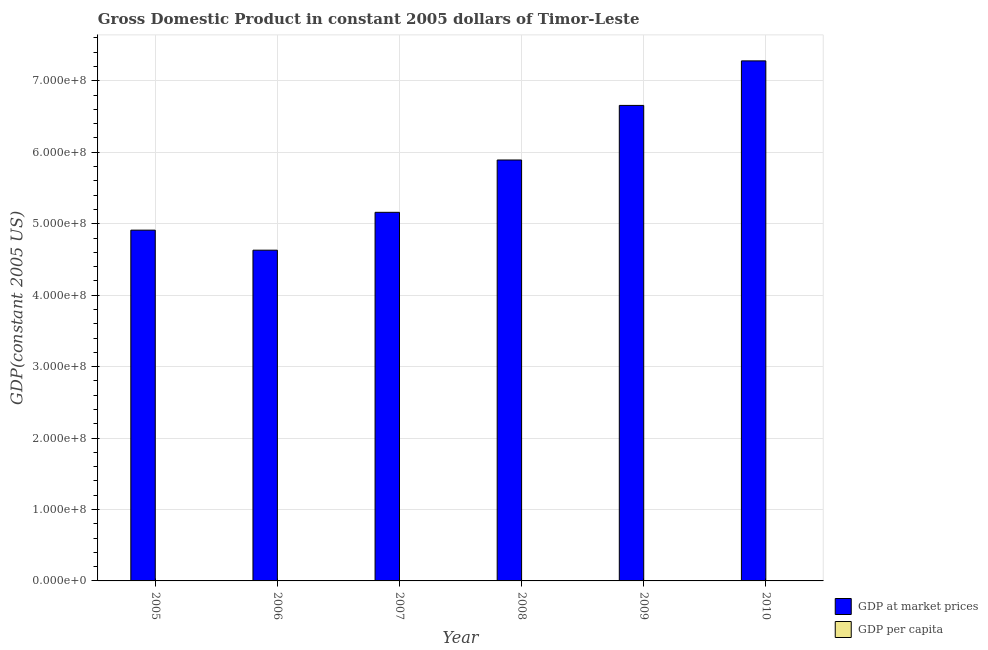How many different coloured bars are there?
Offer a very short reply. 2. How many groups of bars are there?
Give a very brief answer. 6. Are the number of bars per tick equal to the number of legend labels?
Ensure brevity in your answer.  Yes. How many bars are there on the 5th tick from the left?
Provide a short and direct response. 2. How many bars are there on the 1st tick from the right?
Ensure brevity in your answer.  2. In how many cases, is the number of bars for a given year not equal to the number of legend labels?
Your answer should be compact. 0. What is the gdp per capita in 2009?
Offer a very short reply. 634.87. Across all years, what is the maximum gdp per capita?
Offer a very short reply. 682.6. Across all years, what is the minimum gdp per capita?
Provide a short and direct response. 464.78. In which year was the gdp at market prices maximum?
Give a very brief answer. 2010. In which year was the gdp per capita minimum?
Offer a very short reply. 2006. What is the total gdp at market prices in the graph?
Your answer should be compact. 3.45e+09. What is the difference between the gdp per capita in 2007 and that in 2009?
Your response must be concise. -125.65. What is the difference between the gdp at market prices in 2010 and the gdp per capita in 2007?
Offer a very short reply. 2.12e+08. What is the average gdp at market prices per year?
Keep it short and to the point. 5.75e+08. In the year 2007, what is the difference between the gdp per capita and gdp at market prices?
Your answer should be very brief. 0. In how many years, is the gdp per capita greater than 40000000 US$?
Your answer should be very brief. 0. What is the ratio of the gdp at market prices in 2006 to that in 2010?
Ensure brevity in your answer.  0.64. What is the difference between the highest and the second highest gdp per capita?
Keep it short and to the point. 47.73. What is the difference between the highest and the lowest gdp at market prices?
Your answer should be compact. 2.65e+08. What does the 2nd bar from the left in 2006 represents?
Your response must be concise. GDP per capita. What does the 2nd bar from the right in 2010 represents?
Keep it short and to the point. GDP at market prices. Are all the bars in the graph horizontal?
Your answer should be compact. No. How many years are there in the graph?
Your answer should be very brief. 6. What is the difference between two consecutive major ticks on the Y-axis?
Your answer should be compact. 1.00e+08. Does the graph contain any zero values?
Your answer should be very brief. No. Does the graph contain grids?
Give a very brief answer. Yes. How many legend labels are there?
Make the answer very short. 2. How are the legend labels stacked?
Ensure brevity in your answer.  Vertical. What is the title of the graph?
Make the answer very short. Gross Domestic Product in constant 2005 dollars of Timor-Leste. What is the label or title of the Y-axis?
Ensure brevity in your answer.  GDP(constant 2005 US). What is the GDP(constant 2005 US) in GDP at market prices in 2005?
Make the answer very short. 4.91e+08. What is the GDP(constant 2005 US) of GDP per capita in 2005?
Your answer should be compact. 501.43. What is the GDP(constant 2005 US) of GDP at market prices in 2006?
Keep it short and to the point. 4.63e+08. What is the GDP(constant 2005 US) in GDP per capita in 2006?
Make the answer very short. 464.78. What is the GDP(constant 2005 US) of GDP at market prices in 2007?
Your answer should be compact. 5.16e+08. What is the GDP(constant 2005 US) of GDP per capita in 2007?
Make the answer very short. 509.22. What is the GDP(constant 2005 US) in GDP at market prices in 2008?
Make the answer very short. 5.89e+08. What is the GDP(constant 2005 US) in GDP per capita in 2008?
Keep it short and to the point. 571.69. What is the GDP(constant 2005 US) in GDP at market prices in 2009?
Give a very brief answer. 6.66e+08. What is the GDP(constant 2005 US) in GDP per capita in 2009?
Give a very brief answer. 634.87. What is the GDP(constant 2005 US) of GDP at market prices in 2010?
Give a very brief answer. 7.28e+08. What is the GDP(constant 2005 US) in GDP per capita in 2010?
Provide a succinct answer. 682.6. Across all years, what is the maximum GDP(constant 2005 US) in GDP at market prices?
Your answer should be compact. 7.28e+08. Across all years, what is the maximum GDP(constant 2005 US) in GDP per capita?
Provide a succinct answer. 682.6. Across all years, what is the minimum GDP(constant 2005 US) in GDP at market prices?
Your answer should be compact. 4.63e+08. Across all years, what is the minimum GDP(constant 2005 US) in GDP per capita?
Your response must be concise. 464.78. What is the total GDP(constant 2005 US) of GDP at market prices in the graph?
Ensure brevity in your answer.  3.45e+09. What is the total GDP(constant 2005 US) of GDP per capita in the graph?
Your answer should be compact. 3364.58. What is the difference between the GDP(constant 2005 US) of GDP at market prices in 2005 and that in 2006?
Make the answer very short. 2.81e+07. What is the difference between the GDP(constant 2005 US) in GDP per capita in 2005 and that in 2006?
Provide a succinct answer. 36.65. What is the difference between the GDP(constant 2005 US) in GDP at market prices in 2005 and that in 2007?
Give a very brief answer. -2.49e+07. What is the difference between the GDP(constant 2005 US) of GDP per capita in 2005 and that in 2007?
Give a very brief answer. -7.79. What is the difference between the GDP(constant 2005 US) in GDP at market prices in 2005 and that in 2008?
Offer a very short reply. -9.82e+07. What is the difference between the GDP(constant 2005 US) of GDP per capita in 2005 and that in 2008?
Offer a very short reply. -70.26. What is the difference between the GDP(constant 2005 US) of GDP at market prices in 2005 and that in 2009?
Keep it short and to the point. -1.75e+08. What is the difference between the GDP(constant 2005 US) of GDP per capita in 2005 and that in 2009?
Provide a succinct answer. -133.44. What is the difference between the GDP(constant 2005 US) of GDP at market prices in 2005 and that in 2010?
Offer a terse response. -2.37e+08. What is the difference between the GDP(constant 2005 US) in GDP per capita in 2005 and that in 2010?
Provide a short and direct response. -181.17. What is the difference between the GDP(constant 2005 US) of GDP at market prices in 2006 and that in 2007?
Ensure brevity in your answer.  -5.30e+07. What is the difference between the GDP(constant 2005 US) of GDP per capita in 2006 and that in 2007?
Keep it short and to the point. -44.44. What is the difference between the GDP(constant 2005 US) of GDP at market prices in 2006 and that in 2008?
Give a very brief answer. -1.26e+08. What is the difference between the GDP(constant 2005 US) of GDP per capita in 2006 and that in 2008?
Your response must be concise. -106.91. What is the difference between the GDP(constant 2005 US) in GDP at market prices in 2006 and that in 2009?
Give a very brief answer. -2.03e+08. What is the difference between the GDP(constant 2005 US) in GDP per capita in 2006 and that in 2009?
Make the answer very short. -170.09. What is the difference between the GDP(constant 2005 US) of GDP at market prices in 2006 and that in 2010?
Give a very brief answer. -2.65e+08. What is the difference between the GDP(constant 2005 US) of GDP per capita in 2006 and that in 2010?
Provide a short and direct response. -217.82. What is the difference between the GDP(constant 2005 US) of GDP at market prices in 2007 and that in 2008?
Ensure brevity in your answer.  -7.33e+07. What is the difference between the GDP(constant 2005 US) of GDP per capita in 2007 and that in 2008?
Make the answer very short. -62.47. What is the difference between the GDP(constant 2005 US) of GDP at market prices in 2007 and that in 2009?
Offer a very short reply. -1.50e+08. What is the difference between the GDP(constant 2005 US) in GDP per capita in 2007 and that in 2009?
Make the answer very short. -125.65. What is the difference between the GDP(constant 2005 US) of GDP at market prices in 2007 and that in 2010?
Make the answer very short. -2.12e+08. What is the difference between the GDP(constant 2005 US) of GDP per capita in 2007 and that in 2010?
Provide a succinct answer. -173.38. What is the difference between the GDP(constant 2005 US) in GDP at market prices in 2008 and that in 2009?
Your answer should be compact. -7.64e+07. What is the difference between the GDP(constant 2005 US) of GDP per capita in 2008 and that in 2009?
Make the answer very short. -63.18. What is the difference between the GDP(constant 2005 US) of GDP at market prices in 2008 and that in 2010?
Keep it short and to the point. -1.39e+08. What is the difference between the GDP(constant 2005 US) of GDP per capita in 2008 and that in 2010?
Ensure brevity in your answer.  -110.91. What is the difference between the GDP(constant 2005 US) of GDP at market prices in 2009 and that in 2010?
Provide a succinct answer. -6.23e+07. What is the difference between the GDP(constant 2005 US) of GDP per capita in 2009 and that in 2010?
Give a very brief answer. -47.73. What is the difference between the GDP(constant 2005 US) of GDP at market prices in 2005 and the GDP(constant 2005 US) of GDP per capita in 2006?
Make the answer very short. 4.91e+08. What is the difference between the GDP(constant 2005 US) of GDP at market prices in 2005 and the GDP(constant 2005 US) of GDP per capita in 2007?
Provide a succinct answer. 4.91e+08. What is the difference between the GDP(constant 2005 US) of GDP at market prices in 2005 and the GDP(constant 2005 US) of GDP per capita in 2008?
Your response must be concise. 4.91e+08. What is the difference between the GDP(constant 2005 US) in GDP at market prices in 2005 and the GDP(constant 2005 US) in GDP per capita in 2009?
Your response must be concise. 4.91e+08. What is the difference between the GDP(constant 2005 US) of GDP at market prices in 2005 and the GDP(constant 2005 US) of GDP per capita in 2010?
Your answer should be compact. 4.91e+08. What is the difference between the GDP(constant 2005 US) in GDP at market prices in 2006 and the GDP(constant 2005 US) in GDP per capita in 2007?
Make the answer very short. 4.63e+08. What is the difference between the GDP(constant 2005 US) of GDP at market prices in 2006 and the GDP(constant 2005 US) of GDP per capita in 2008?
Keep it short and to the point. 4.63e+08. What is the difference between the GDP(constant 2005 US) of GDP at market prices in 2006 and the GDP(constant 2005 US) of GDP per capita in 2009?
Ensure brevity in your answer.  4.63e+08. What is the difference between the GDP(constant 2005 US) of GDP at market prices in 2006 and the GDP(constant 2005 US) of GDP per capita in 2010?
Provide a short and direct response. 4.63e+08. What is the difference between the GDP(constant 2005 US) of GDP at market prices in 2007 and the GDP(constant 2005 US) of GDP per capita in 2008?
Provide a succinct answer. 5.16e+08. What is the difference between the GDP(constant 2005 US) in GDP at market prices in 2007 and the GDP(constant 2005 US) in GDP per capita in 2009?
Make the answer very short. 5.16e+08. What is the difference between the GDP(constant 2005 US) of GDP at market prices in 2007 and the GDP(constant 2005 US) of GDP per capita in 2010?
Keep it short and to the point. 5.16e+08. What is the difference between the GDP(constant 2005 US) in GDP at market prices in 2008 and the GDP(constant 2005 US) in GDP per capita in 2009?
Your response must be concise. 5.89e+08. What is the difference between the GDP(constant 2005 US) in GDP at market prices in 2008 and the GDP(constant 2005 US) in GDP per capita in 2010?
Make the answer very short. 5.89e+08. What is the difference between the GDP(constant 2005 US) of GDP at market prices in 2009 and the GDP(constant 2005 US) of GDP per capita in 2010?
Offer a very short reply. 6.66e+08. What is the average GDP(constant 2005 US) in GDP at market prices per year?
Make the answer very short. 5.75e+08. What is the average GDP(constant 2005 US) in GDP per capita per year?
Your answer should be very brief. 560.76. In the year 2005, what is the difference between the GDP(constant 2005 US) in GDP at market prices and GDP(constant 2005 US) in GDP per capita?
Your response must be concise. 4.91e+08. In the year 2006, what is the difference between the GDP(constant 2005 US) of GDP at market prices and GDP(constant 2005 US) of GDP per capita?
Your answer should be very brief. 4.63e+08. In the year 2007, what is the difference between the GDP(constant 2005 US) of GDP at market prices and GDP(constant 2005 US) of GDP per capita?
Your answer should be compact. 5.16e+08. In the year 2008, what is the difference between the GDP(constant 2005 US) of GDP at market prices and GDP(constant 2005 US) of GDP per capita?
Make the answer very short. 5.89e+08. In the year 2009, what is the difference between the GDP(constant 2005 US) of GDP at market prices and GDP(constant 2005 US) of GDP per capita?
Provide a short and direct response. 6.66e+08. In the year 2010, what is the difference between the GDP(constant 2005 US) of GDP at market prices and GDP(constant 2005 US) of GDP per capita?
Your answer should be compact. 7.28e+08. What is the ratio of the GDP(constant 2005 US) of GDP at market prices in 2005 to that in 2006?
Offer a very short reply. 1.06. What is the ratio of the GDP(constant 2005 US) of GDP per capita in 2005 to that in 2006?
Give a very brief answer. 1.08. What is the ratio of the GDP(constant 2005 US) in GDP at market prices in 2005 to that in 2007?
Your answer should be compact. 0.95. What is the ratio of the GDP(constant 2005 US) of GDP per capita in 2005 to that in 2007?
Offer a very short reply. 0.98. What is the ratio of the GDP(constant 2005 US) of GDP per capita in 2005 to that in 2008?
Provide a succinct answer. 0.88. What is the ratio of the GDP(constant 2005 US) in GDP at market prices in 2005 to that in 2009?
Provide a succinct answer. 0.74. What is the ratio of the GDP(constant 2005 US) of GDP per capita in 2005 to that in 2009?
Give a very brief answer. 0.79. What is the ratio of the GDP(constant 2005 US) in GDP at market prices in 2005 to that in 2010?
Provide a succinct answer. 0.67. What is the ratio of the GDP(constant 2005 US) in GDP per capita in 2005 to that in 2010?
Make the answer very short. 0.73. What is the ratio of the GDP(constant 2005 US) in GDP at market prices in 2006 to that in 2007?
Provide a succinct answer. 0.9. What is the ratio of the GDP(constant 2005 US) in GDP per capita in 2006 to that in 2007?
Offer a very short reply. 0.91. What is the ratio of the GDP(constant 2005 US) in GDP at market prices in 2006 to that in 2008?
Provide a short and direct response. 0.79. What is the ratio of the GDP(constant 2005 US) of GDP per capita in 2006 to that in 2008?
Keep it short and to the point. 0.81. What is the ratio of the GDP(constant 2005 US) of GDP at market prices in 2006 to that in 2009?
Your answer should be very brief. 0.7. What is the ratio of the GDP(constant 2005 US) in GDP per capita in 2006 to that in 2009?
Provide a succinct answer. 0.73. What is the ratio of the GDP(constant 2005 US) of GDP at market prices in 2006 to that in 2010?
Your response must be concise. 0.64. What is the ratio of the GDP(constant 2005 US) of GDP per capita in 2006 to that in 2010?
Give a very brief answer. 0.68. What is the ratio of the GDP(constant 2005 US) in GDP at market prices in 2007 to that in 2008?
Ensure brevity in your answer.  0.88. What is the ratio of the GDP(constant 2005 US) in GDP per capita in 2007 to that in 2008?
Provide a short and direct response. 0.89. What is the ratio of the GDP(constant 2005 US) in GDP at market prices in 2007 to that in 2009?
Provide a short and direct response. 0.78. What is the ratio of the GDP(constant 2005 US) of GDP per capita in 2007 to that in 2009?
Provide a short and direct response. 0.8. What is the ratio of the GDP(constant 2005 US) in GDP at market prices in 2007 to that in 2010?
Offer a terse response. 0.71. What is the ratio of the GDP(constant 2005 US) of GDP per capita in 2007 to that in 2010?
Your answer should be very brief. 0.75. What is the ratio of the GDP(constant 2005 US) in GDP at market prices in 2008 to that in 2009?
Keep it short and to the point. 0.89. What is the ratio of the GDP(constant 2005 US) of GDP per capita in 2008 to that in 2009?
Keep it short and to the point. 0.9. What is the ratio of the GDP(constant 2005 US) in GDP at market prices in 2008 to that in 2010?
Offer a very short reply. 0.81. What is the ratio of the GDP(constant 2005 US) of GDP per capita in 2008 to that in 2010?
Your answer should be compact. 0.84. What is the ratio of the GDP(constant 2005 US) of GDP at market prices in 2009 to that in 2010?
Offer a very short reply. 0.91. What is the ratio of the GDP(constant 2005 US) in GDP per capita in 2009 to that in 2010?
Your response must be concise. 0.93. What is the difference between the highest and the second highest GDP(constant 2005 US) of GDP at market prices?
Give a very brief answer. 6.23e+07. What is the difference between the highest and the second highest GDP(constant 2005 US) of GDP per capita?
Ensure brevity in your answer.  47.73. What is the difference between the highest and the lowest GDP(constant 2005 US) of GDP at market prices?
Offer a very short reply. 2.65e+08. What is the difference between the highest and the lowest GDP(constant 2005 US) in GDP per capita?
Keep it short and to the point. 217.82. 